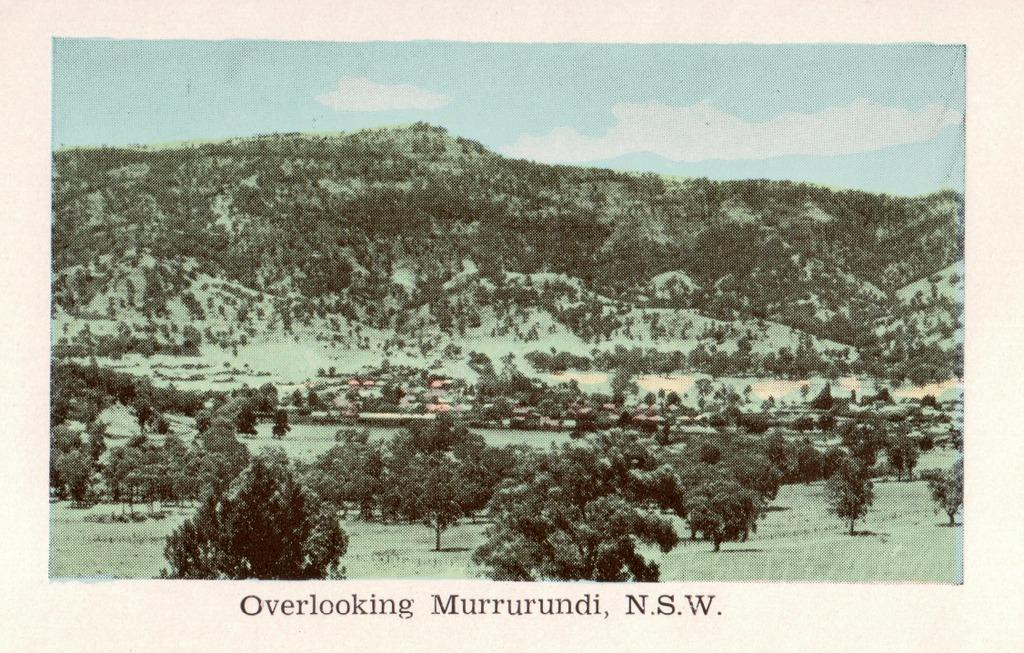What type of vegetation can be seen in the image? There are trees and plants in the image. Is there any text present in the image? Yes, there is text written on the image. What can be seen in the distance in the image? There is a mountain in the background of the image. Can you tell me what type of offer is being made by the wrist in the image? There is no wrist or offer present in the image; it features trees, plants, text, and a mountain. 